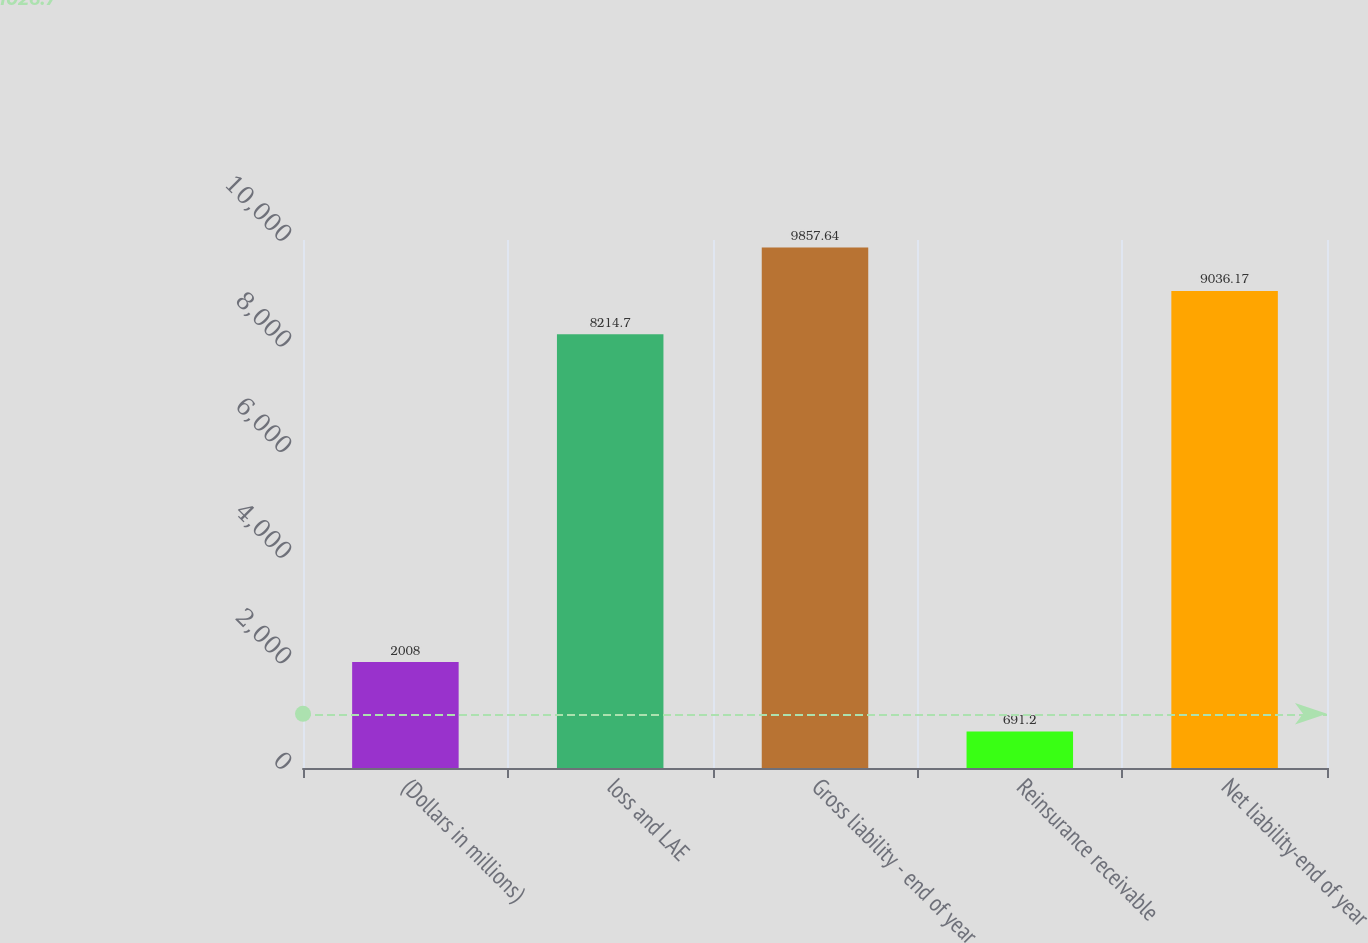<chart> <loc_0><loc_0><loc_500><loc_500><bar_chart><fcel>(Dollars in millions)<fcel>loss and LAE<fcel>Gross liability - end of year<fcel>Reinsurance receivable<fcel>Net liability-end of year<nl><fcel>2008<fcel>8214.7<fcel>9857.64<fcel>691.2<fcel>9036.17<nl></chart> 